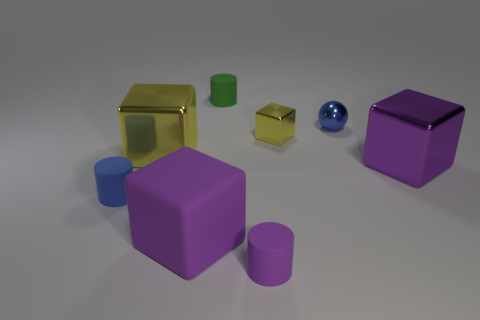Subtract all shiny blocks. How many blocks are left? 1 Add 1 matte cylinders. How many objects exist? 9 Subtract all cylinders. How many objects are left? 5 Subtract all gray cylinders. Subtract all gray spheres. How many cylinders are left? 3 Add 7 green rubber cylinders. How many green rubber cylinders exist? 8 Subtract 0 brown cylinders. How many objects are left? 8 Subtract all small purple matte cylinders. Subtract all small objects. How many objects are left? 2 Add 4 big purple matte things. How many big purple matte things are left? 5 